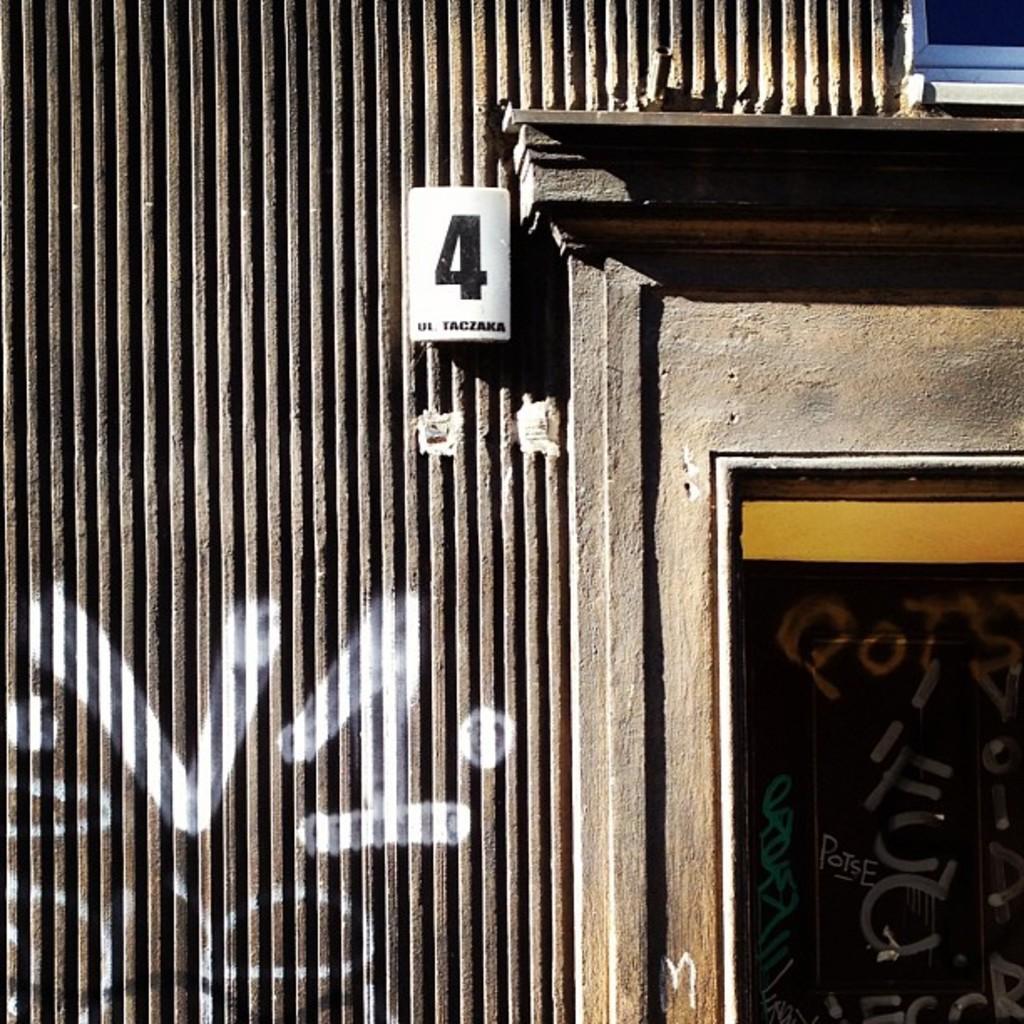Please provide a concise description of this image. In this image there is a wall as we can see in middle of this image and there is a white color board at top of this image and the number is written on it. 